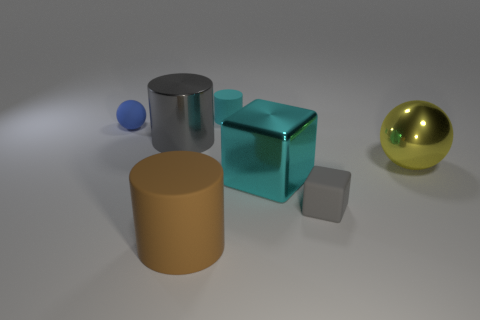Subtract all brown cylinders. How many cylinders are left? 2 Subtract all cyan cylinders. How many cylinders are left? 2 Add 4 gray matte things. How many gray matte things are left? 5 Add 5 gray matte things. How many gray matte things exist? 6 Add 1 brown rubber cubes. How many objects exist? 8 Subtract 0 green cylinders. How many objects are left? 7 Subtract all blocks. How many objects are left? 5 Subtract 1 blocks. How many blocks are left? 1 Subtract all green blocks. Subtract all red spheres. How many blocks are left? 2 Subtract all red balls. How many gray cylinders are left? 1 